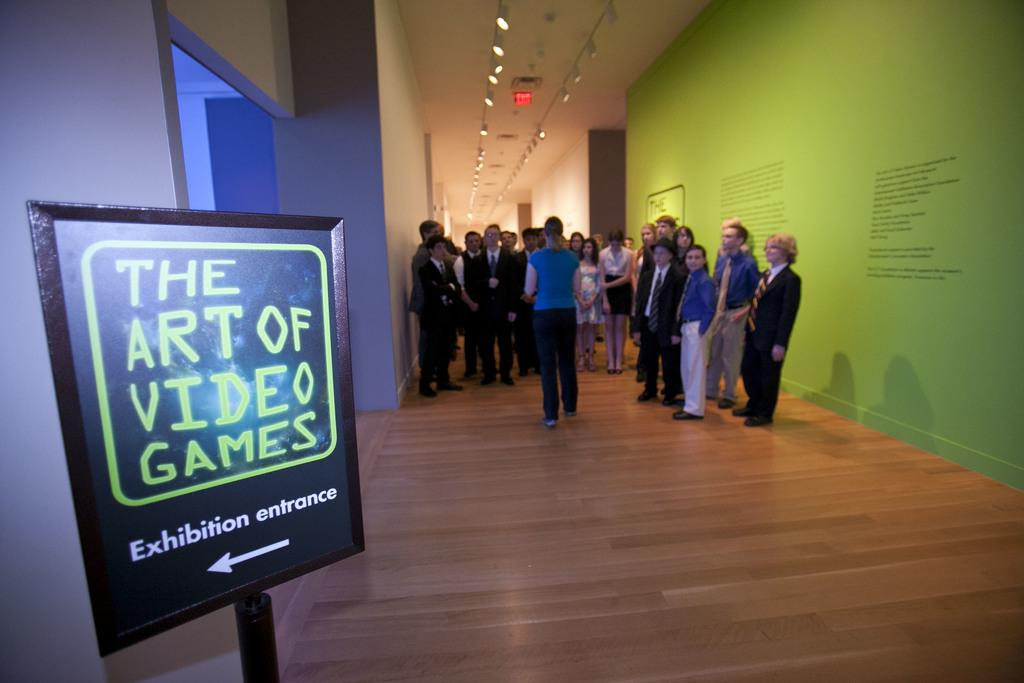<image>
Relay a brief, clear account of the picture shown. People on a guided tour which is leading to The Art of Video Games exhibition entrance. 